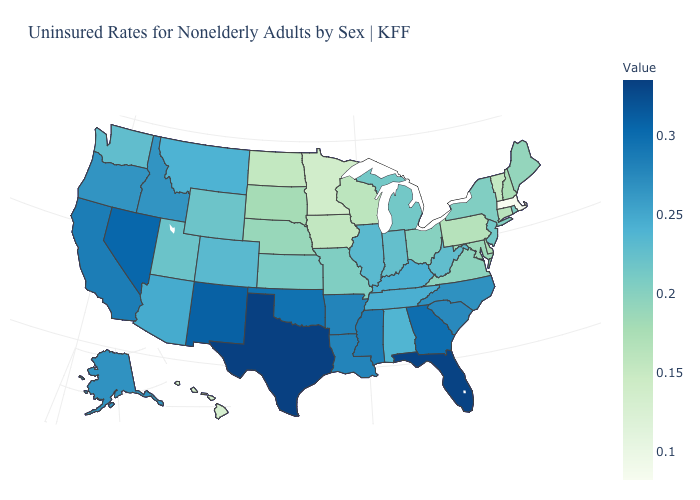Does Massachusetts have the lowest value in the USA?
Quick response, please. Yes. Which states have the lowest value in the West?
Concise answer only. Hawaii. Which states have the lowest value in the MidWest?
Quick response, please. Minnesota. Does Kentucky have the highest value in the South?
Answer briefly. No. Among the states that border Georgia , does Florida have the highest value?
Write a very short answer. Yes. Among the states that border Illinois , which have the lowest value?
Concise answer only. Iowa. Does New Mexico have a higher value than Minnesota?
Keep it brief. Yes. 